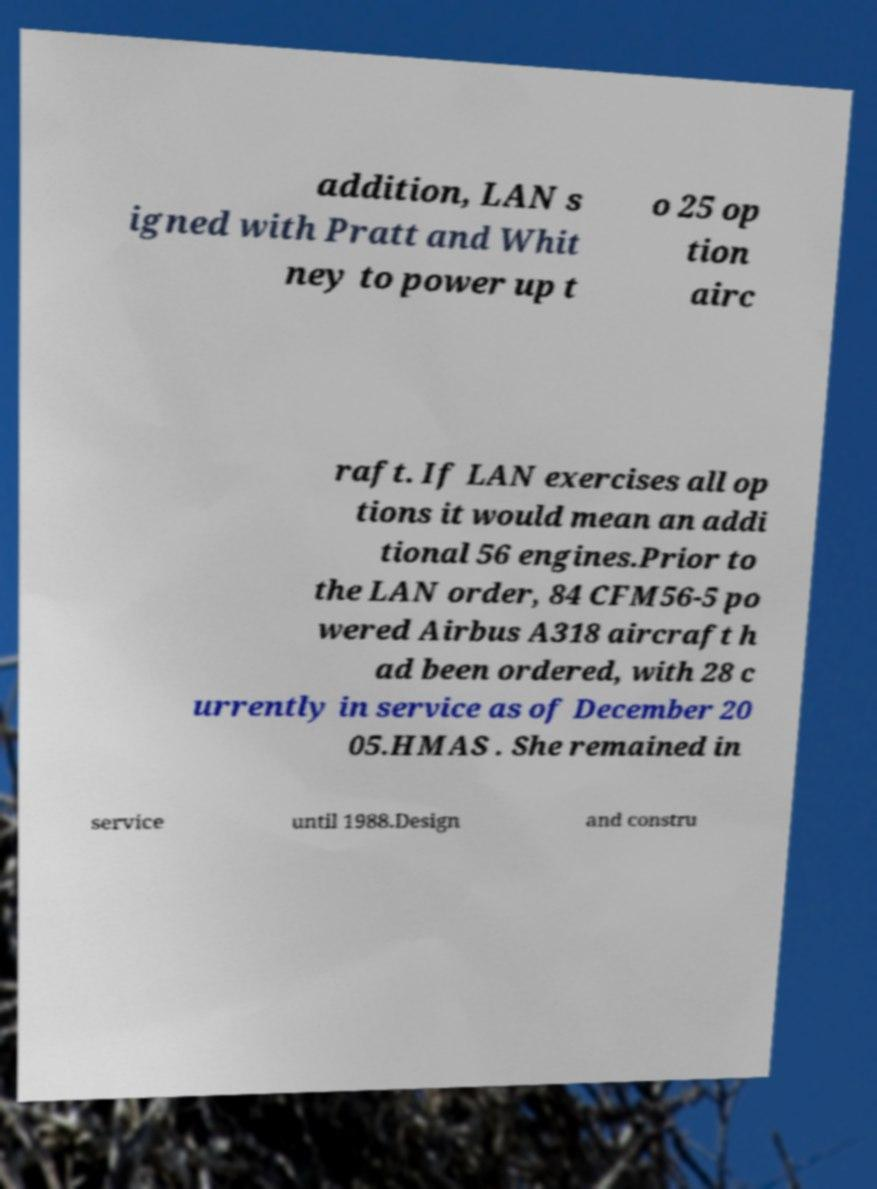Could you assist in decoding the text presented in this image and type it out clearly? addition, LAN s igned with Pratt and Whit ney to power up t o 25 op tion airc raft. If LAN exercises all op tions it would mean an addi tional 56 engines.Prior to the LAN order, 84 CFM56-5 po wered Airbus A318 aircraft h ad been ordered, with 28 c urrently in service as of December 20 05.HMAS . She remained in service until 1988.Design and constru 